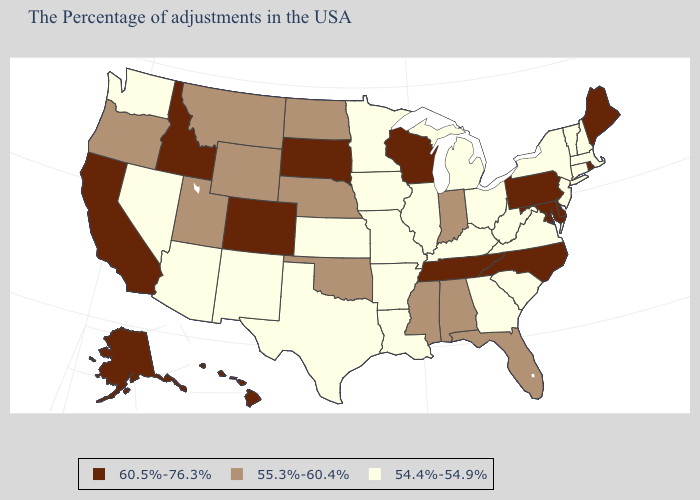Among the states that border New York , which have the highest value?
Be succinct. Pennsylvania. Among the states that border Georgia , which have the highest value?
Be succinct. North Carolina, Tennessee. Is the legend a continuous bar?
Concise answer only. No. Name the states that have a value in the range 55.3%-60.4%?
Answer briefly. Florida, Indiana, Alabama, Mississippi, Nebraska, Oklahoma, North Dakota, Wyoming, Utah, Montana, Oregon. Name the states that have a value in the range 54.4%-54.9%?
Short answer required. Massachusetts, New Hampshire, Vermont, Connecticut, New York, New Jersey, Virginia, South Carolina, West Virginia, Ohio, Georgia, Michigan, Kentucky, Illinois, Louisiana, Missouri, Arkansas, Minnesota, Iowa, Kansas, Texas, New Mexico, Arizona, Nevada, Washington. How many symbols are there in the legend?
Be succinct. 3. How many symbols are there in the legend?
Give a very brief answer. 3. Among the states that border Nebraska , does Missouri have the lowest value?
Write a very short answer. Yes. Does the map have missing data?
Answer briefly. No. How many symbols are there in the legend?
Short answer required. 3. Among the states that border Kentucky , does Tennessee have the highest value?
Give a very brief answer. Yes. Does Oklahoma have the highest value in the South?
Write a very short answer. No. Does Hawaii have the highest value in the USA?
Write a very short answer. Yes. What is the lowest value in the MidWest?
Write a very short answer. 54.4%-54.9%. What is the highest value in the USA?
Quick response, please. 60.5%-76.3%. 